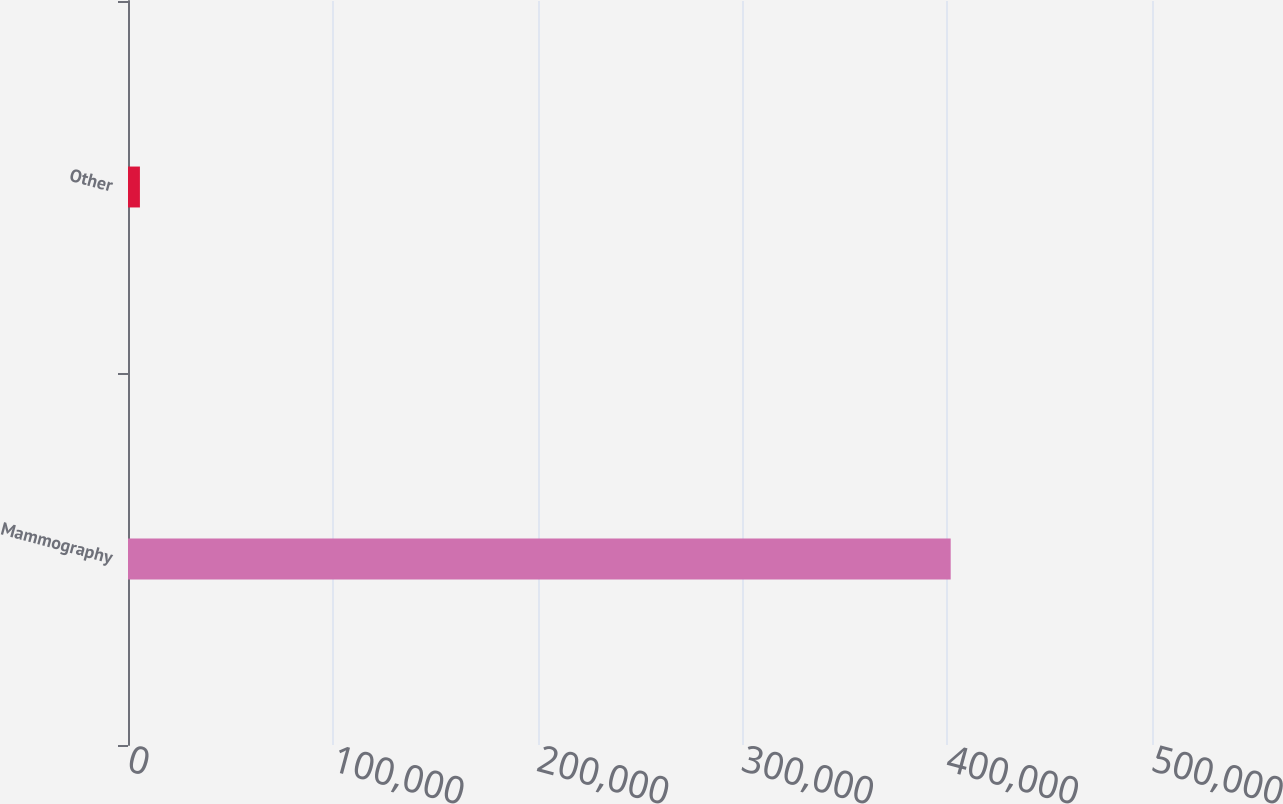<chart> <loc_0><loc_0><loc_500><loc_500><bar_chart><fcel>Mammography<fcel>Other<nl><fcel>401711<fcel>5817<nl></chart> 